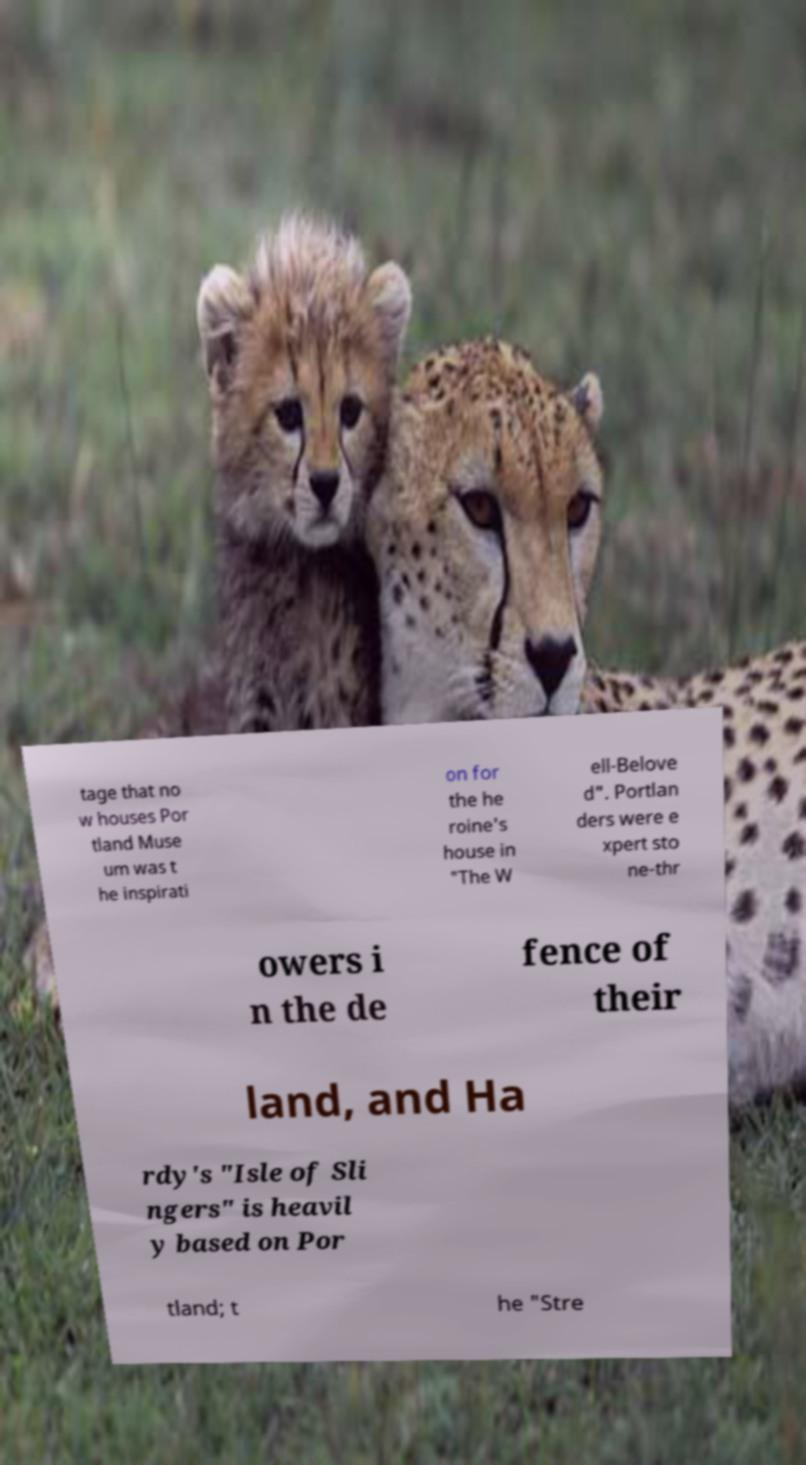Please read and relay the text visible in this image. What does it say? tage that no w houses Por tland Muse um was t he inspirati on for the he roine's house in "The W ell-Belove d". Portlan ders were e xpert sto ne-thr owers i n the de fence of their land, and Ha rdy's "Isle of Sli ngers" is heavil y based on Por tland; t he "Stre 